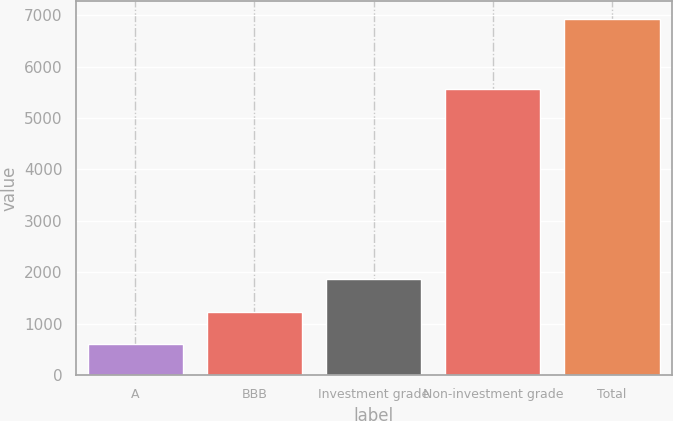Convert chart. <chart><loc_0><loc_0><loc_500><loc_500><bar_chart><fcel>A<fcel>BBB<fcel>Investment grade<fcel>Non-investment grade<fcel>Total<nl><fcel>598<fcel>1230.4<fcel>1862.8<fcel>5572<fcel>6922<nl></chart> 